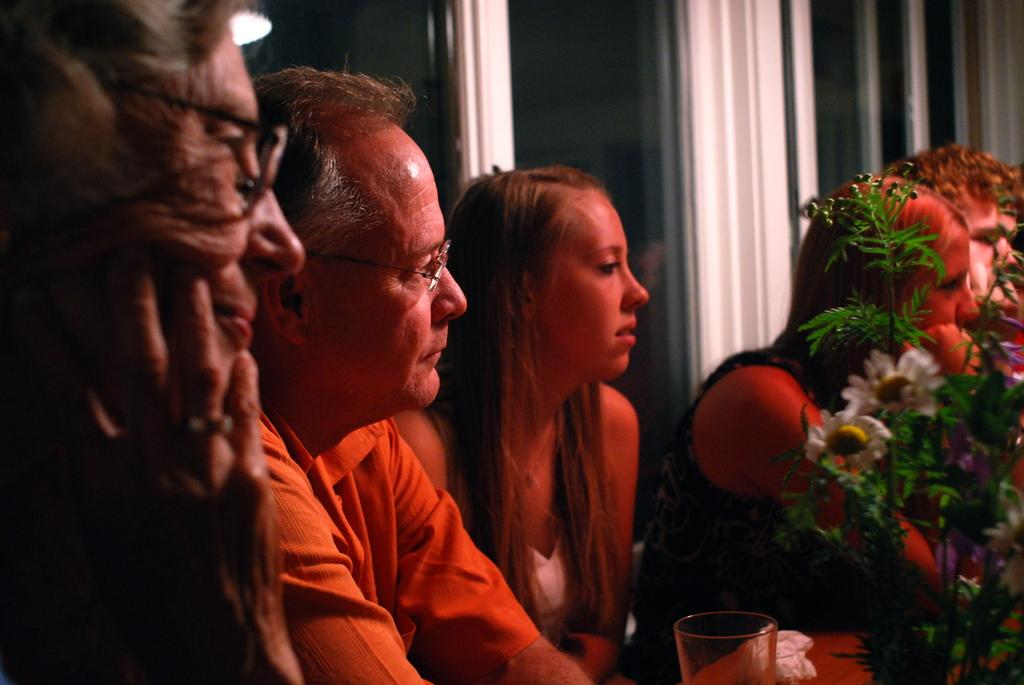Who or what can be seen in the image? There are people in the image. What else is present in the image besides the people? A: There is a potted plant in the image. What type of prison can be seen in the image? There is no prison present in the image; it features people and a potted plant. What kind of chin is visible on the potted plant in the image? Potted plants do not have chins, as they are inanimate objects. 